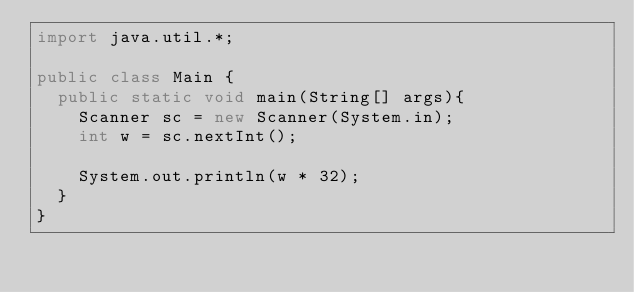<code> <loc_0><loc_0><loc_500><loc_500><_Java_>import java.util.*;

public class Main {
  public static void main(String[] args){
    Scanner sc = new Scanner(System.in);
    int w = sc.nextInt();

    System.out.println(w * 32);
  }
}
</code> 